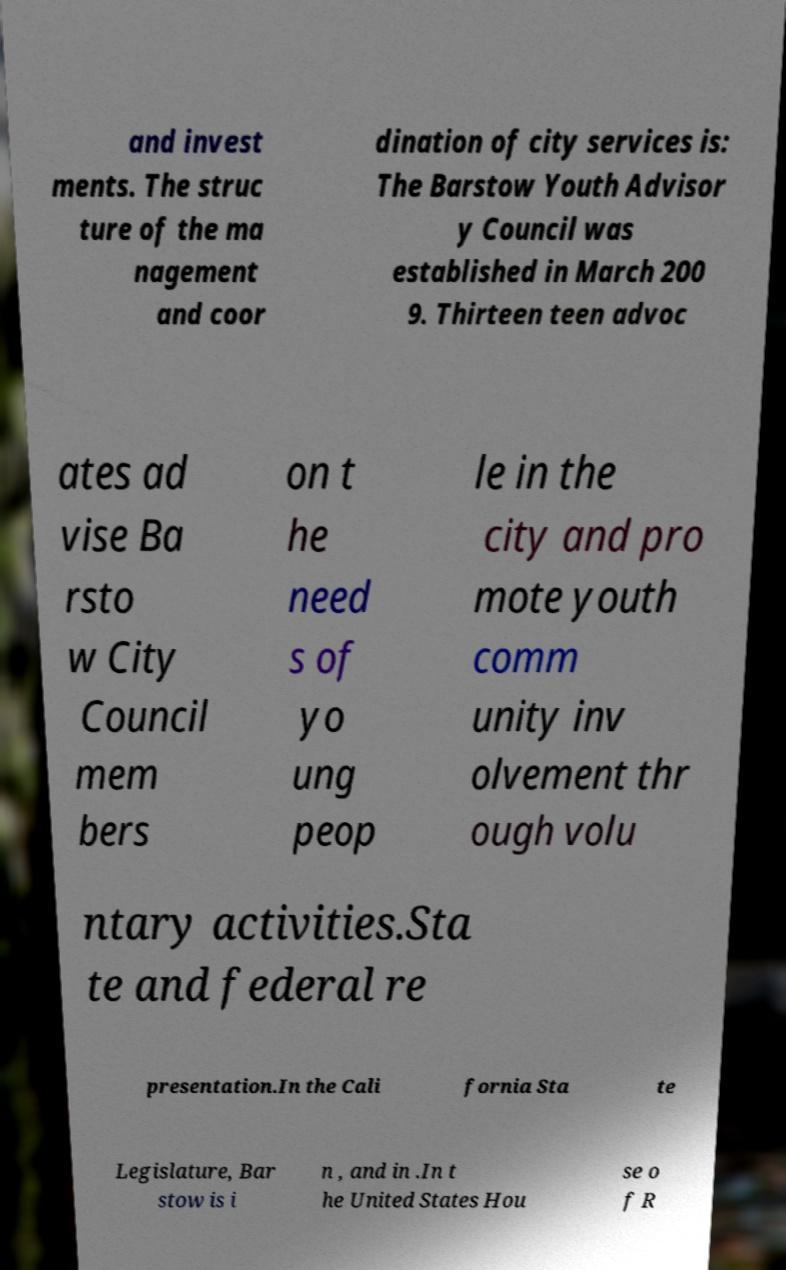Can you accurately transcribe the text from the provided image for me? and invest ments. The struc ture of the ma nagement and coor dination of city services is: The Barstow Youth Advisor y Council was established in March 200 9. Thirteen teen advoc ates ad vise Ba rsto w City Council mem bers on t he need s of yo ung peop le in the city and pro mote youth comm unity inv olvement thr ough volu ntary activities.Sta te and federal re presentation.In the Cali fornia Sta te Legislature, Bar stow is i n , and in .In t he United States Hou se o f R 